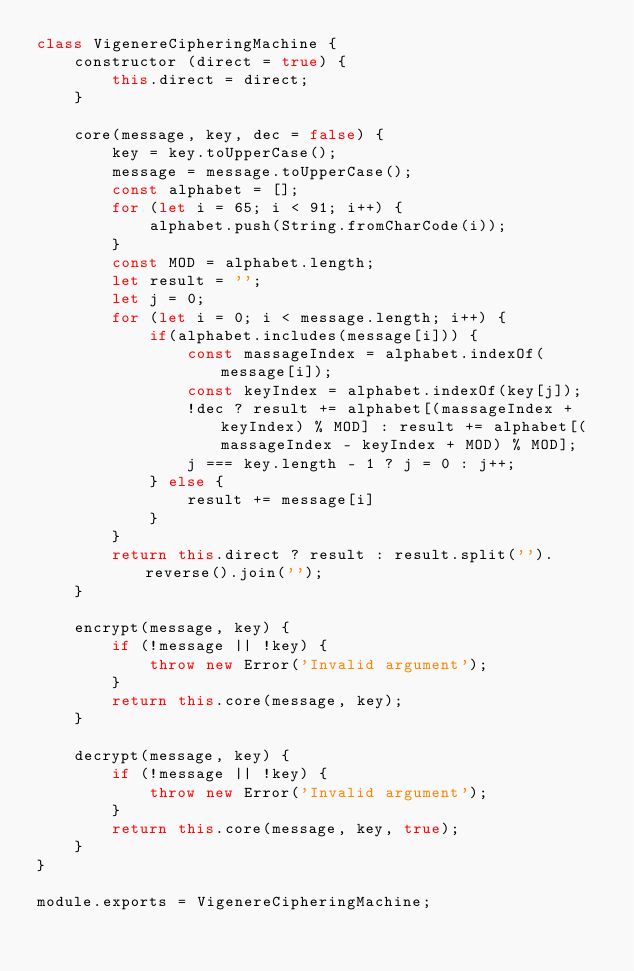Convert code to text. <code><loc_0><loc_0><loc_500><loc_500><_JavaScript_>class VigenereCipheringMachine {
    constructor (direct = true) {
        this.direct = direct;
    }

    core(message, key, dec = false) {
        key = key.toUpperCase();
        message = message.toUpperCase();
        const alphabet = [];
        for (let i = 65; i < 91; i++) {
            alphabet.push(String.fromCharCode(i));
        }
        const MOD = alphabet.length;
        let result = '';
        let j = 0;
        for (let i = 0; i < message.length; i++) {
            if(alphabet.includes(message[i])) {
                const massageIndex = alphabet.indexOf(message[i]);
                const keyIndex = alphabet.indexOf(key[j]);
                !dec ? result += alphabet[(massageIndex + keyIndex) % MOD] : result += alphabet[(massageIndex - keyIndex + MOD) % MOD];
                j === key.length - 1 ? j = 0 : j++;
            } else {
                result += message[i]
            }
        }
        return this.direct ? result : result.split('').reverse().join('');
    }

    encrypt(message, key) {
        if (!message || !key) {
            throw new Error('Invalid argument');
        }
        return this.core(message, key);
    }

    decrypt(message, key) {
        if (!message || !key) {
            throw new Error('Invalid argument');
        }
        return this.core(message, key, true);
    }
}

module.exports = VigenereCipheringMachine;
</code> 